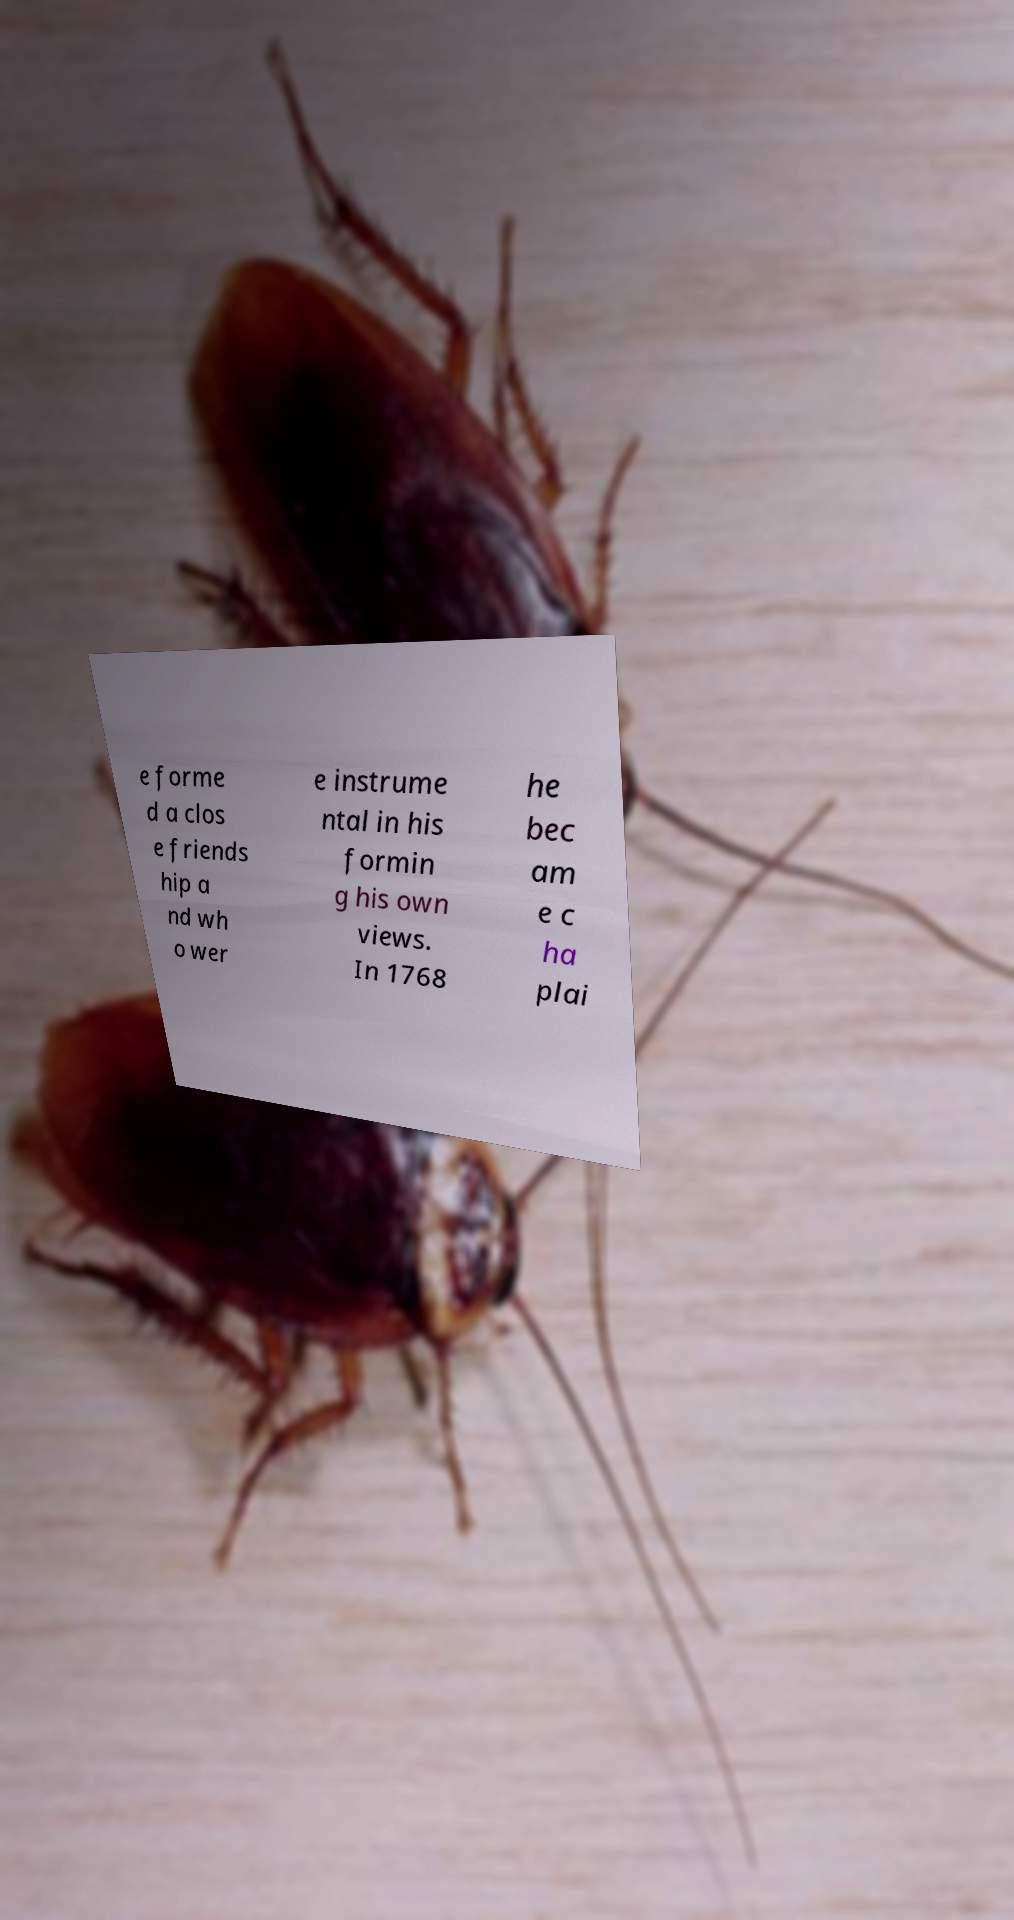Please identify and transcribe the text found in this image. e forme d a clos e friends hip a nd wh o wer e instrume ntal in his formin g his own views. In 1768 he bec am e c ha plai 